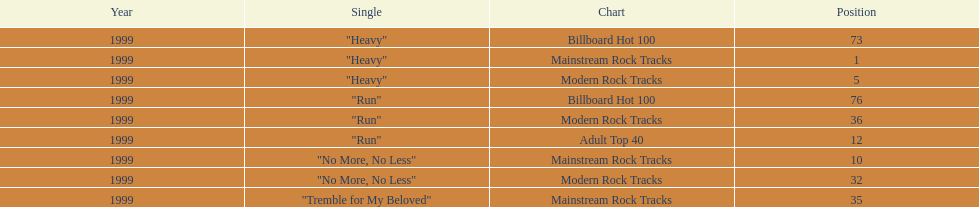Which of the singles from "dosage" had the highest billboard hot 100 rating? "Heavy". 